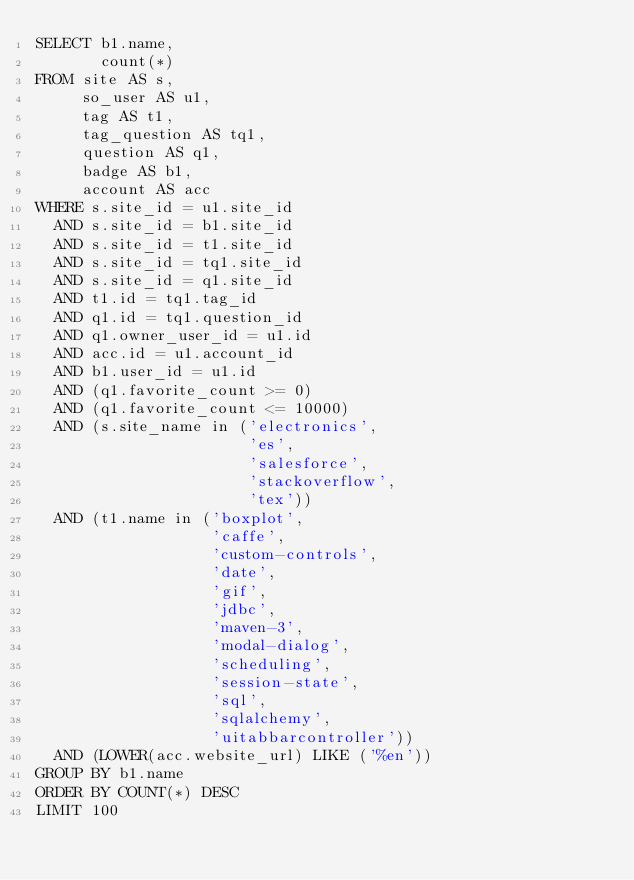Convert code to text. <code><loc_0><loc_0><loc_500><loc_500><_SQL_>SELECT b1.name,
       count(*)
FROM site AS s,
     so_user AS u1,
     tag AS t1,
     tag_question AS tq1,
     question AS q1,
     badge AS b1,
     account AS acc
WHERE s.site_id = u1.site_id
  AND s.site_id = b1.site_id
  AND s.site_id = t1.site_id
  AND s.site_id = tq1.site_id
  AND s.site_id = q1.site_id
  AND t1.id = tq1.tag_id
  AND q1.id = tq1.question_id
  AND q1.owner_user_id = u1.id
  AND acc.id = u1.account_id
  AND b1.user_id = u1.id
  AND (q1.favorite_count >= 0)
  AND (q1.favorite_count <= 10000)
  AND (s.site_name in ('electronics',
                       'es',
                       'salesforce',
                       'stackoverflow',
                       'tex'))
  AND (t1.name in ('boxplot',
                   'caffe',
                   'custom-controls',
                   'date',
                   'gif',
                   'jdbc',
                   'maven-3',
                   'modal-dialog',
                   'scheduling',
                   'session-state',
                   'sql',
                   'sqlalchemy',
                   'uitabbarcontroller'))
  AND (LOWER(acc.website_url) LIKE ('%en'))
GROUP BY b1.name
ORDER BY COUNT(*) DESC
LIMIT 100</code> 